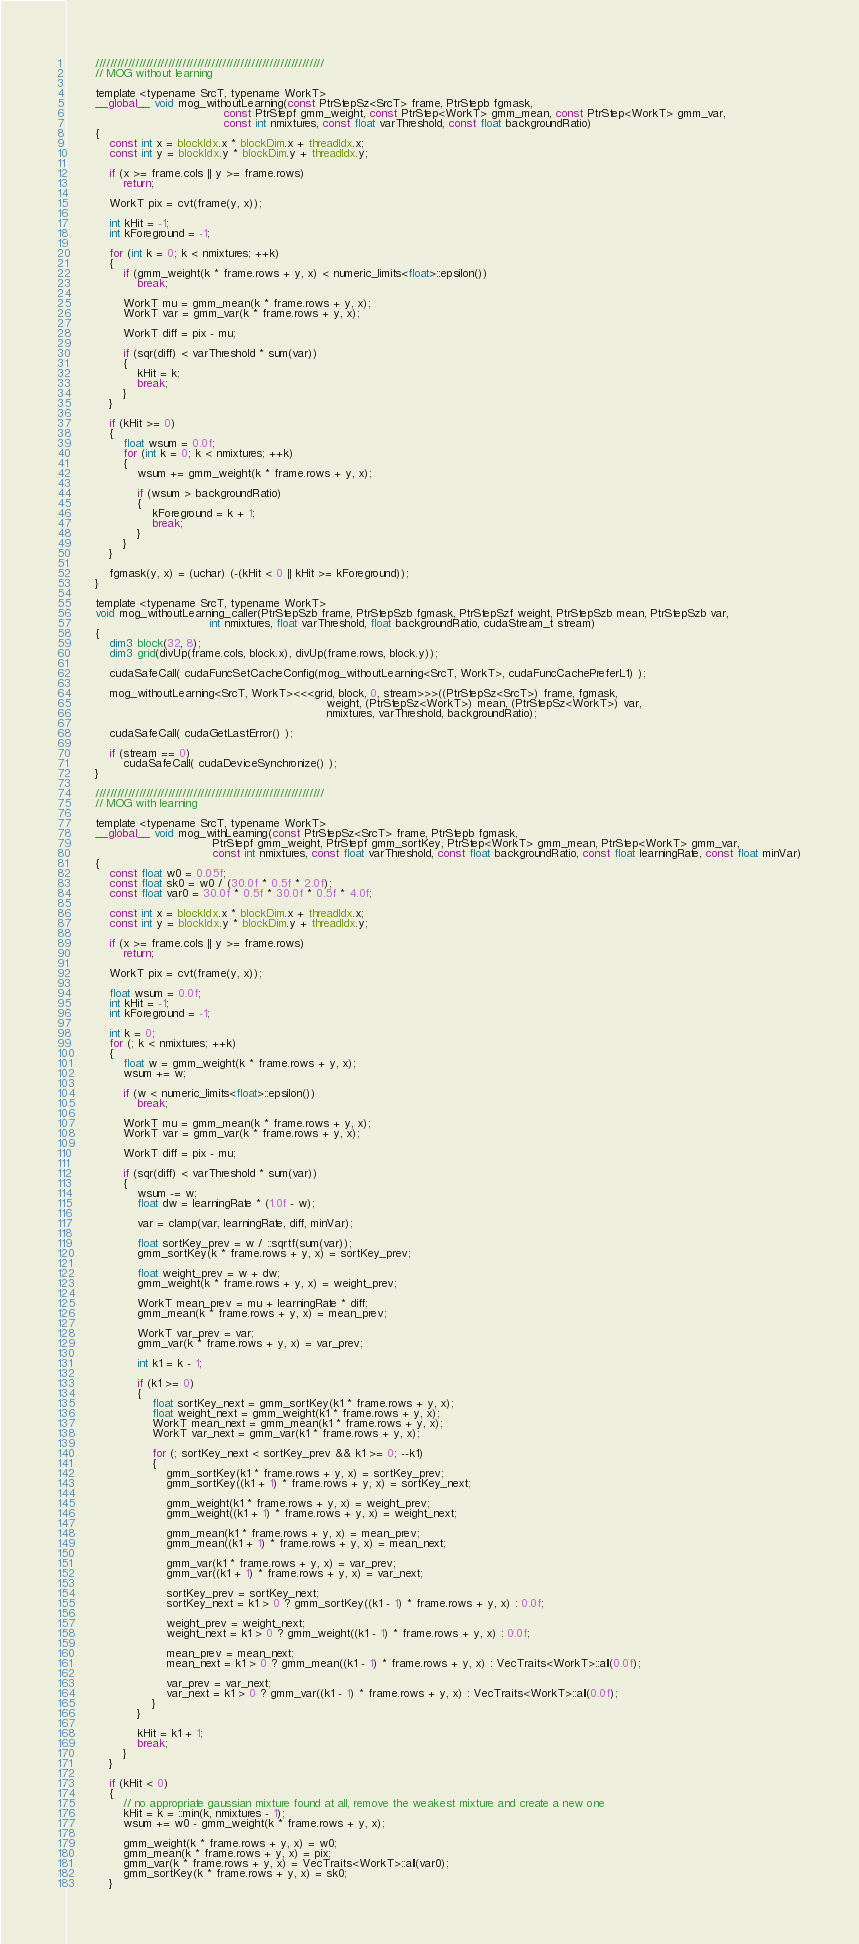<code> <loc_0><loc_0><loc_500><loc_500><_Cuda_>        ///////////////////////////////////////////////////////////////
        // MOG without learning

        template <typename SrcT, typename WorkT>
        __global__ void mog_withoutLearning(const PtrStepSz<SrcT> frame, PtrStepb fgmask,
                                            const PtrStepf gmm_weight, const PtrStep<WorkT> gmm_mean, const PtrStep<WorkT> gmm_var,
                                            const int nmixtures, const float varThreshold, const float backgroundRatio)
        {
            const int x = blockIdx.x * blockDim.x + threadIdx.x;
            const int y = blockIdx.y * blockDim.y + threadIdx.y;

            if (x >= frame.cols || y >= frame.rows)
                return;

            WorkT pix = cvt(frame(y, x));

            int kHit = -1;
            int kForeground = -1;

            for (int k = 0; k < nmixtures; ++k)
            {
                if (gmm_weight(k * frame.rows + y, x) < numeric_limits<float>::epsilon())
                    break;

                WorkT mu = gmm_mean(k * frame.rows + y, x);
                WorkT var = gmm_var(k * frame.rows + y, x);

                WorkT diff = pix - mu;

                if (sqr(diff) < varThreshold * sum(var))
                {
                    kHit = k;
                    break;
                }
            }

            if (kHit >= 0)
            {
                float wsum = 0.0f;
                for (int k = 0; k < nmixtures; ++k)
                {
                    wsum += gmm_weight(k * frame.rows + y, x);

                    if (wsum > backgroundRatio)
                    {
                        kForeground = k + 1;
                        break;
                    }
                }
            }

            fgmask(y, x) = (uchar) (-(kHit < 0 || kHit >= kForeground));
        }

        template <typename SrcT, typename WorkT>
        void mog_withoutLearning_caller(PtrStepSzb frame, PtrStepSzb fgmask, PtrStepSzf weight, PtrStepSzb mean, PtrStepSzb var,
                                        int nmixtures, float varThreshold, float backgroundRatio, cudaStream_t stream)
        {
            dim3 block(32, 8);
            dim3 grid(divUp(frame.cols, block.x), divUp(frame.rows, block.y));

            cudaSafeCall( cudaFuncSetCacheConfig(mog_withoutLearning<SrcT, WorkT>, cudaFuncCachePreferL1) );

            mog_withoutLearning<SrcT, WorkT><<<grid, block, 0, stream>>>((PtrStepSz<SrcT>) frame, fgmask,
                                                                         weight, (PtrStepSz<WorkT>) mean, (PtrStepSz<WorkT>) var,
                                                                         nmixtures, varThreshold, backgroundRatio);

            cudaSafeCall( cudaGetLastError() );

            if (stream == 0)
                cudaSafeCall( cudaDeviceSynchronize() );
        }

        ///////////////////////////////////////////////////////////////
        // MOG with learning

        template <typename SrcT, typename WorkT>
        __global__ void mog_withLearning(const PtrStepSz<SrcT> frame, PtrStepb fgmask,
                                         PtrStepf gmm_weight, PtrStepf gmm_sortKey, PtrStep<WorkT> gmm_mean, PtrStep<WorkT> gmm_var,
                                         const int nmixtures, const float varThreshold, const float backgroundRatio, const float learningRate, const float minVar)
        {
            const float w0 = 0.05f;
            const float sk0 = w0 / (30.0f * 0.5f * 2.0f);
            const float var0 = 30.0f * 0.5f * 30.0f * 0.5f * 4.0f;

            const int x = blockIdx.x * blockDim.x + threadIdx.x;
            const int y = blockIdx.y * blockDim.y + threadIdx.y;

            if (x >= frame.cols || y >= frame.rows)
                return;

            WorkT pix = cvt(frame(y, x));

            float wsum = 0.0f;
            int kHit = -1;
            int kForeground = -1;

            int k = 0;
            for (; k < nmixtures; ++k)
            {
                float w = gmm_weight(k * frame.rows + y, x);
                wsum += w;

                if (w < numeric_limits<float>::epsilon())
                    break;

                WorkT mu = gmm_mean(k * frame.rows + y, x);
                WorkT var = gmm_var(k * frame.rows + y, x);

                WorkT diff = pix - mu;

                if (sqr(diff) < varThreshold * sum(var))
                {
                    wsum -= w;
                    float dw = learningRate * (1.0f - w);

                    var = clamp(var, learningRate, diff, minVar);

                    float sortKey_prev = w / ::sqrtf(sum(var));
                    gmm_sortKey(k * frame.rows + y, x) = sortKey_prev;

                    float weight_prev = w + dw;
                    gmm_weight(k * frame.rows + y, x) = weight_prev;

                    WorkT mean_prev = mu + learningRate * diff;
                    gmm_mean(k * frame.rows + y, x) = mean_prev;

                    WorkT var_prev = var;
                    gmm_var(k * frame.rows + y, x) = var_prev;

                    int k1 = k - 1;

                    if (k1 >= 0)
                    {
                        float sortKey_next = gmm_sortKey(k1 * frame.rows + y, x);
                        float weight_next = gmm_weight(k1 * frame.rows + y, x);
                        WorkT mean_next = gmm_mean(k1 * frame.rows + y, x);
                        WorkT var_next = gmm_var(k1 * frame.rows + y, x);

                        for (; sortKey_next < sortKey_prev && k1 >= 0; --k1)
                        {
                            gmm_sortKey(k1 * frame.rows + y, x) = sortKey_prev;
                            gmm_sortKey((k1 + 1) * frame.rows + y, x) = sortKey_next;

                            gmm_weight(k1 * frame.rows + y, x) = weight_prev;
                            gmm_weight((k1 + 1) * frame.rows + y, x) = weight_next;

                            gmm_mean(k1 * frame.rows + y, x) = mean_prev;
                            gmm_mean((k1 + 1) * frame.rows + y, x) = mean_next;

                            gmm_var(k1 * frame.rows + y, x) = var_prev;
                            gmm_var((k1 + 1) * frame.rows + y, x) = var_next;

                            sortKey_prev = sortKey_next;
                            sortKey_next = k1 > 0 ? gmm_sortKey((k1 - 1) * frame.rows + y, x) : 0.0f;

                            weight_prev = weight_next;
                            weight_next = k1 > 0 ? gmm_weight((k1 - 1) * frame.rows + y, x) : 0.0f;

                            mean_prev = mean_next;
                            mean_next = k1 > 0 ? gmm_mean((k1 - 1) * frame.rows + y, x) : VecTraits<WorkT>::all(0.0f);

                            var_prev = var_next;
                            var_next = k1 > 0 ? gmm_var((k1 - 1) * frame.rows + y, x) : VecTraits<WorkT>::all(0.0f);
                        }
                    }

                    kHit = k1 + 1;
                    break;
                }
            }

            if (kHit < 0)
            {
                // no appropriate gaussian mixture found at all, remove the weakest mixture and create a new one
                kHit = k = ::min(k, nmixtures - 1);
                wsum += w0 - gmm_weight(k * frame.rows + y, x);

                gmm_weight(k * frame.rows + y, x) = w0;
                gmm_mean(k * frame.rows + y, x) = pix;
                gmm_var(k * frame.rows + y, x) = VecTraits<WorkT>::all(var0);
                gmm_sortKey(k * frame.rows + y, x) = sk0;
            }</code> 